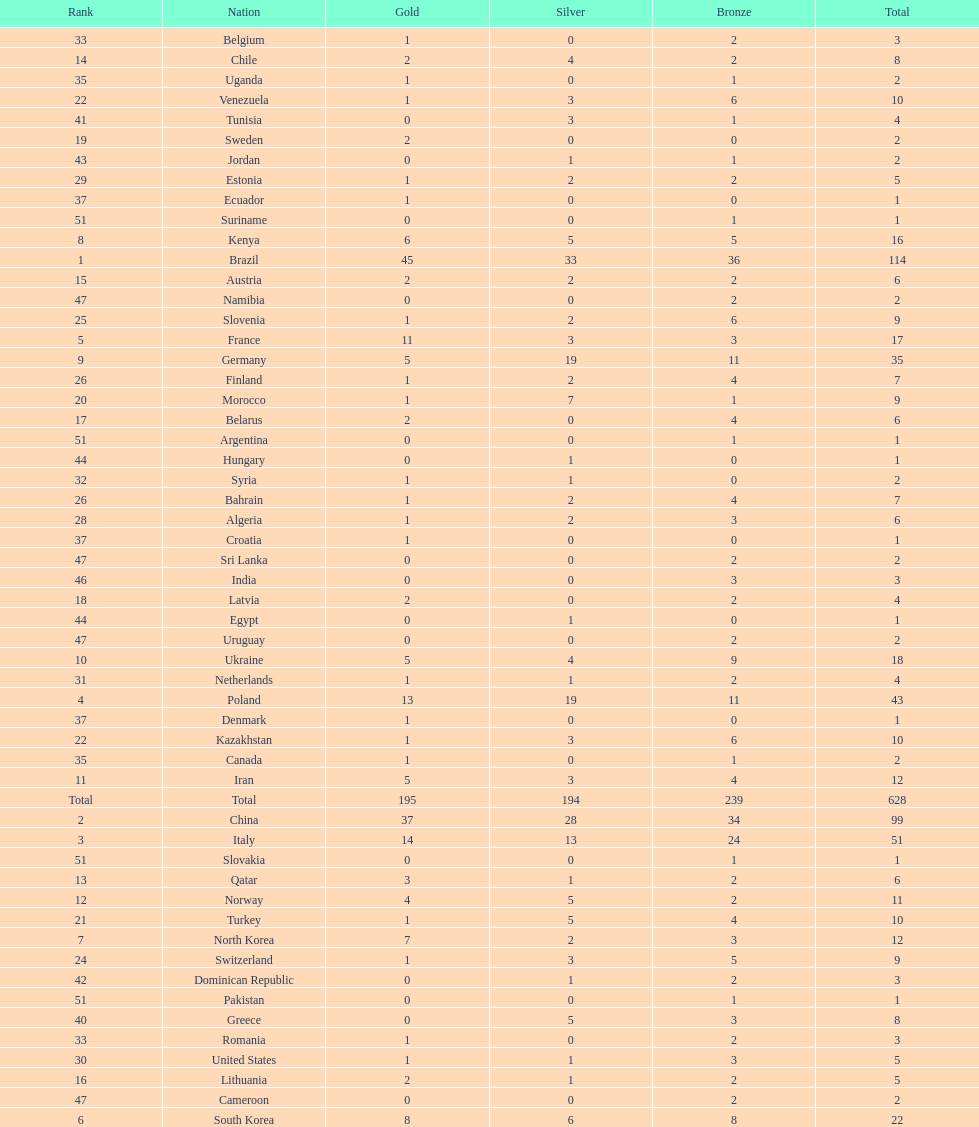How many gold medals did germany earn? 5. 